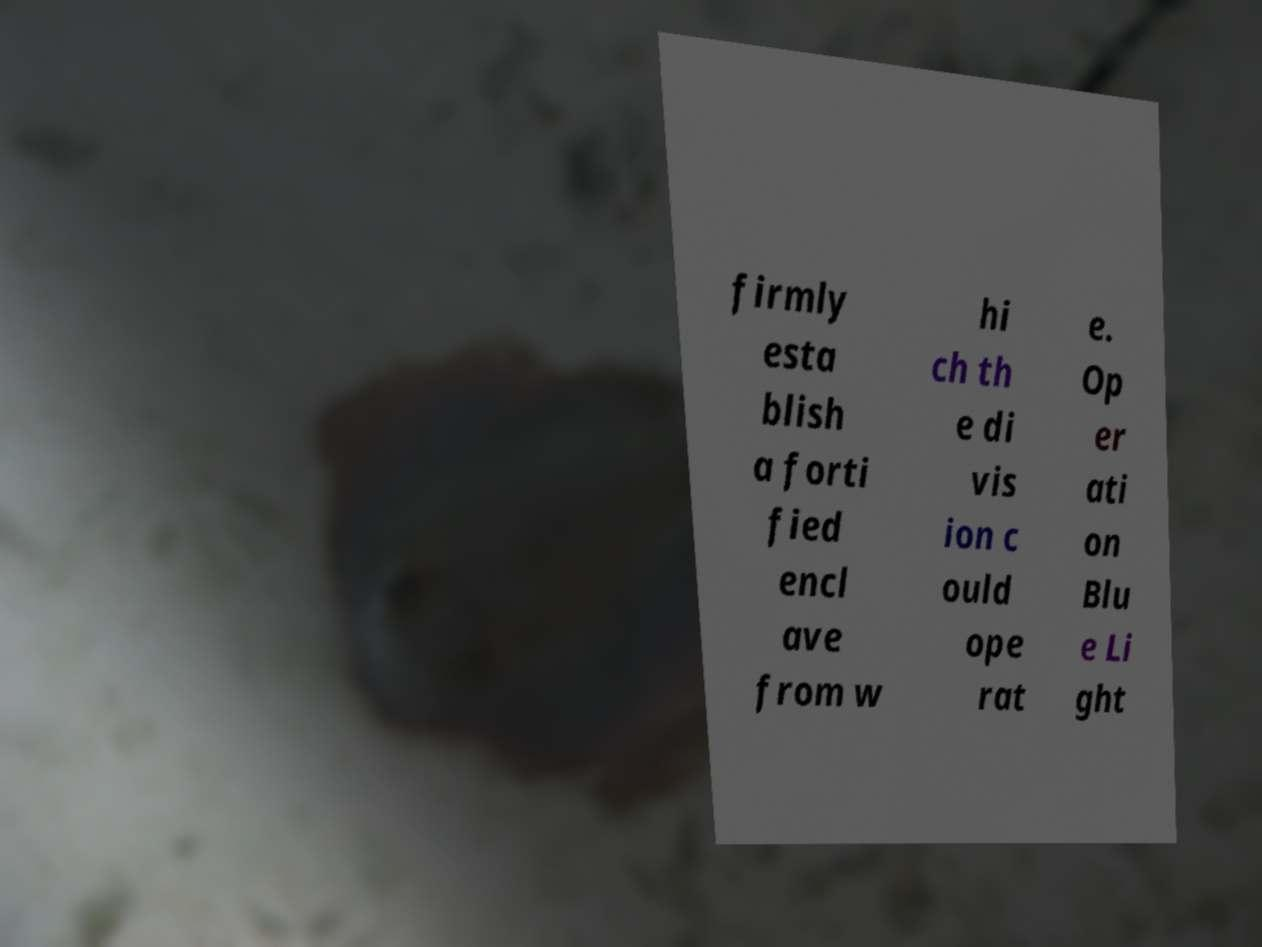Please read and relay the text visible in this image. What does it say? firmly esta blish a forti fied encl ave from w hi ch th e di vis ion c ould ope rat e. Op er ati on Blu e Li ght 